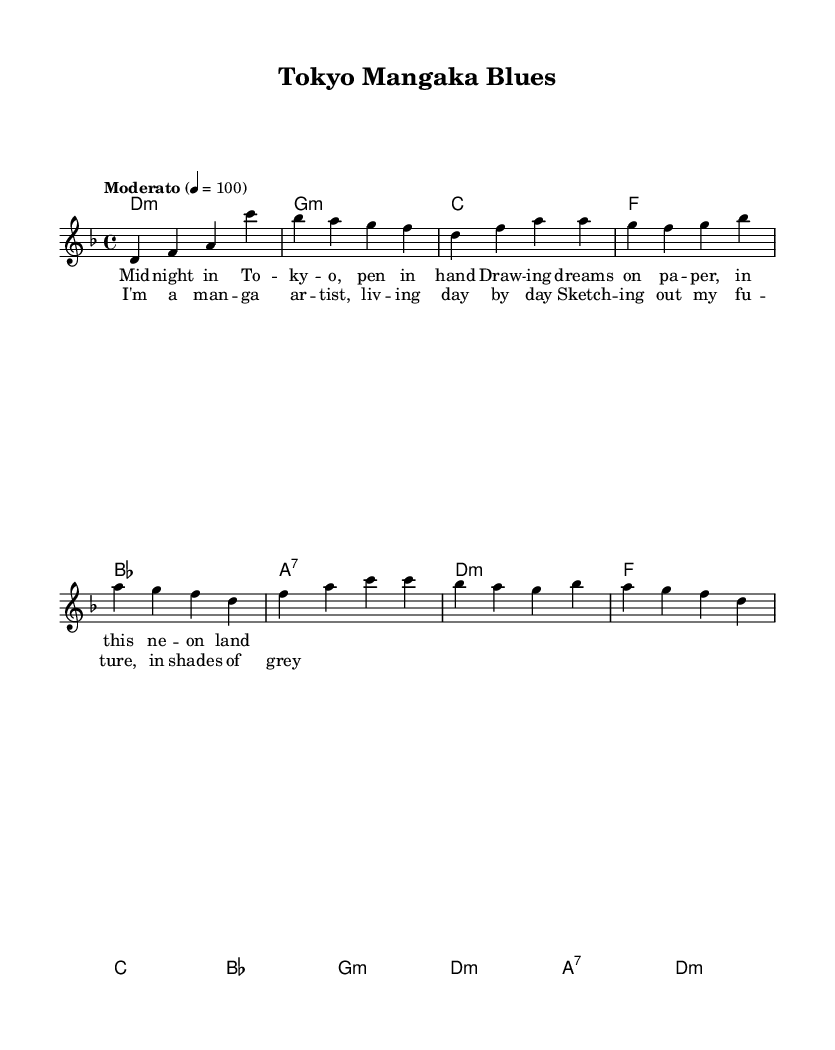What is the key signature of this music? The key signature of the piece is D minor, indicated by the presence of one flat (B flat) in the key signature section.
Answer: D minor What is the time signature? The time signature is indicated as 4/4, which means there are four beats in each measure and the quarter note receives one beat.
Answer: 4/4 What is the tempo marking? The tempo marking indicates a speed of moderato, which is generally understood to mean a moderate pace, and this is further specified with a metronome marking of 100 beats per minute.
Answer: Moderato 4 = 100 How many measures are in the verse section? The verse section consists of a total of six measures as seen in the melody and the accompanying harmonies.
Answer: 6 What type of song is this based on its structure? The song follows a typical folk song structure of verses and a chorus, often telling a story or expressing emotions relevant to the life and experiences of an artist.
Answer: Folk What is the primary theme of the lyrics? The primary theme revolves around the struggles and dreams of a manga artist living in Tokyo, expressed through imagery of drawing and aspirations.
Answer: Life of a manga artist What chord is used at the beginning of the chorus? The chord at the beginning of the chorus is F major, which can be determined by looking at the harmonies directly listed before the chorus section.
Answer: F 